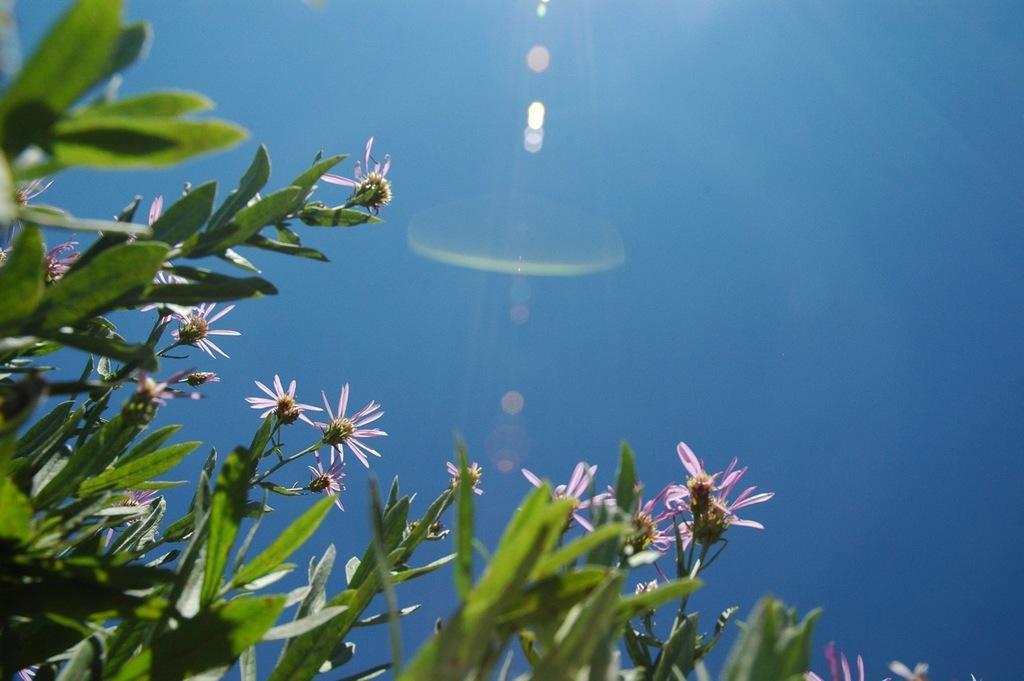Could you give a brief overview of what you see in this image? In this image, I can see the plants with flowers and leaves. These leaves are green in color. I think this is the sky, which is blue in color. 